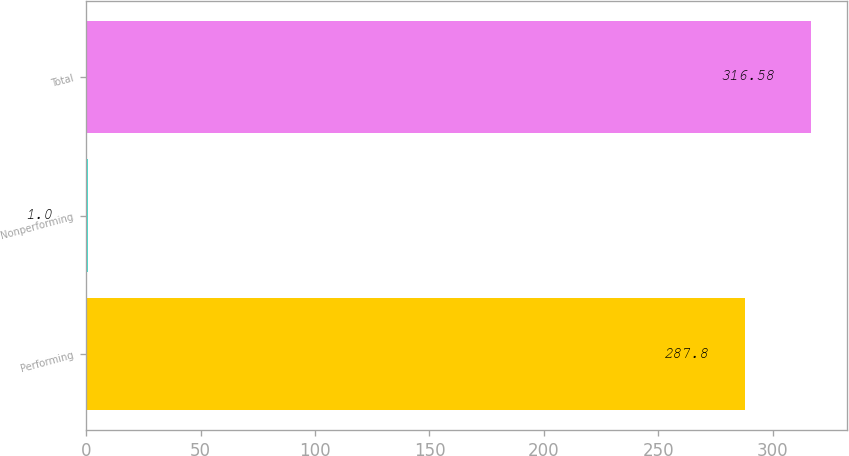Convert chart to OTSL. <chart><loc_0><loc_0><loc_500><loc_500><bar_chart><fcel>Performing<fcel>Nonperforming<fcel>Total<nl><fcel>287.8<fcel>1<fcel>316.58<nl></chart> 